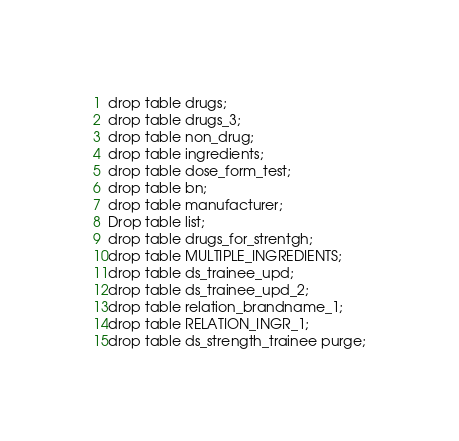<code> <loc_0><loc_0><loc_500><loc_500><_SQL_>drop table drugs;
drop table drugs_3;
drop table non_drug;
drop table ingredients;
drop table dose_form_test;
drop table bn;
drop table manufacturer;
Drop table list;
drop table drugs_for_strentgh;
drop table MULTIPLE_INGREDIENTS;
drop table ds_trainee_upd;
drop table ds_trainee_upd_2;
drop table relation_brandname_1;
drop table RELATION_INGR_1;
drop table ds_strength_trainee purge;

</code> 